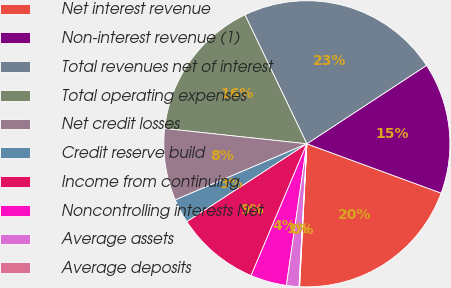Convert chart to OTSL. <chart><loc_0><loc_0><loc_500><loc_500><pie_chart><fcel>Net interest revenue<fcel>Non-interest revenue (1)<fcel>Total revenues net of interest<fcel>Total operating expenses<fcel>Net credit losses<fcel>Credit reserve build<fcel>Income from continuing<fcel>Noncontrolling interests Net<fcel>Average assets<fcel>Average deposits<nl><fcel>20.2%<fcel>14.83%<fcel>22.89%<fcel>16.17%<fcel>8.12%<fcel>2.75%<fcel>9.46%<fcel>4.09%<fcel>1.41%<fcel>0.07%<nl></chart> 